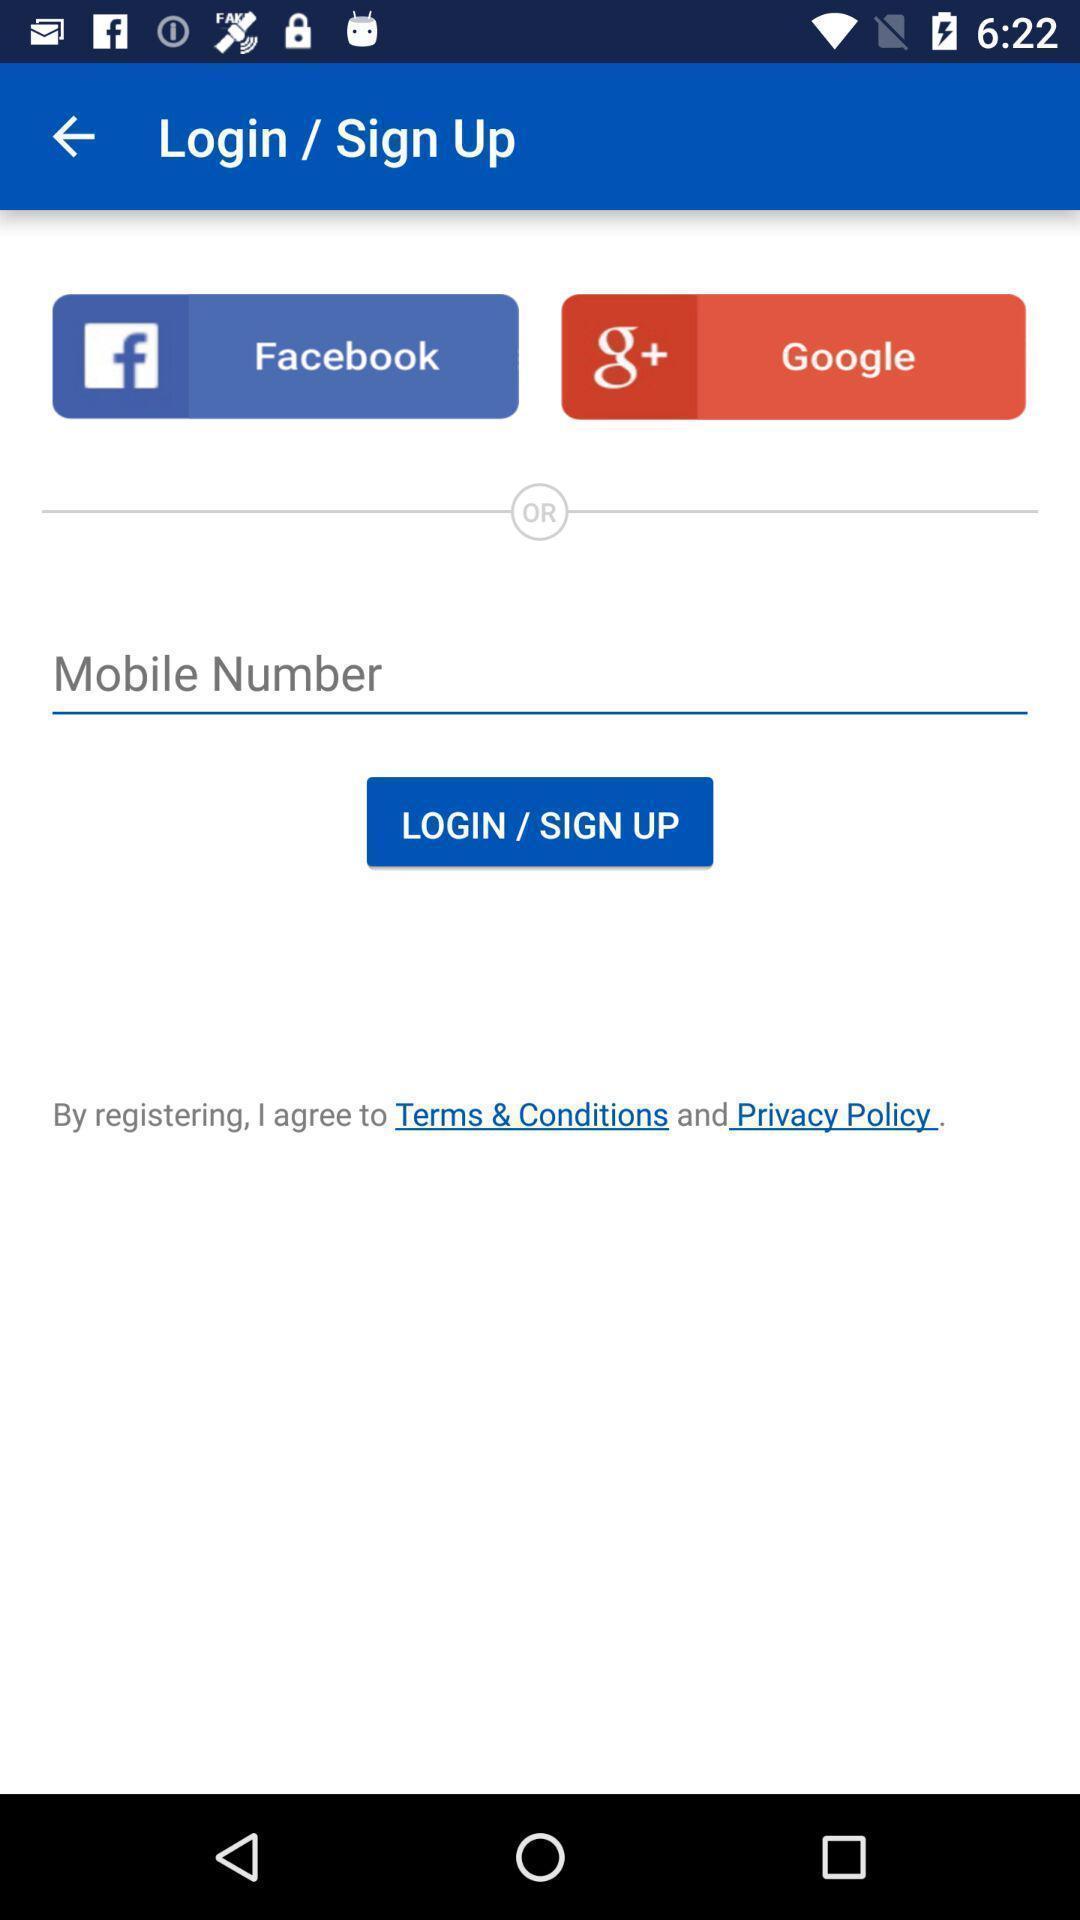Provide a textual representation of this image. Sign up page. 